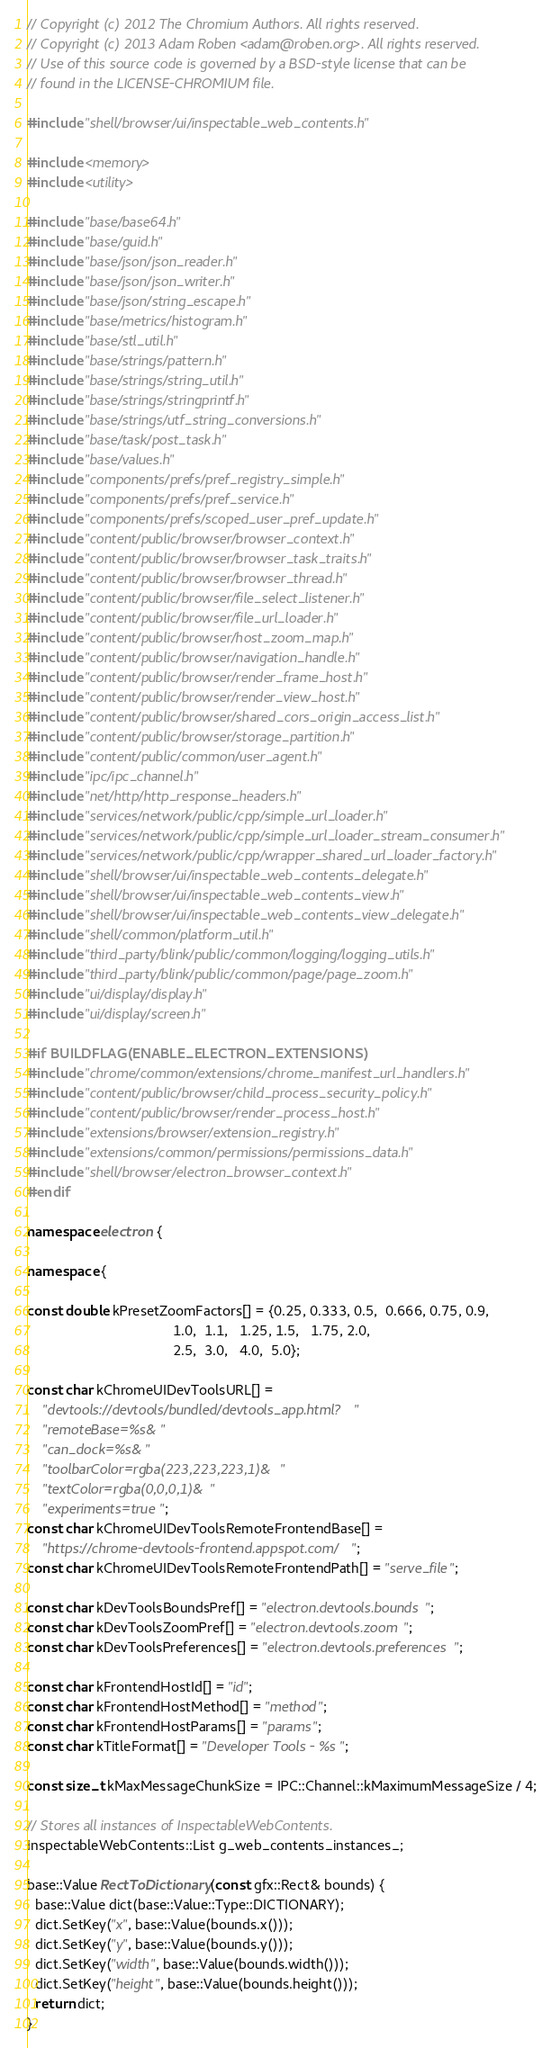<code> <loc_0><loc_0><loc_500><loc_500><_C++_>// Copyright (c) 2012 The Chromium Authors. All rights reserved.
// Copyright (c) 2013 Adam Roben <adam@roben.org>. All rights reserved.
// Use of this source code is governed by a BSD-style license that can be
// found in the LICENSE-CHROMIUM file.

#include "shell/browser/ui/inspectable_web_contents.h"

#include <memory>
#include <utility>

#include "base/base64.h"
#include "base/guid.h"
#include "base/json/json_reader.h"
#include "base/json/json_writer.h"
#include "base/json/string_escape.h"
#include "base/metrics/histogram.h"
#include "base/stl_util.h"
#include "base/strings/pattern.h"
#include "base/strings/string_util.h"
#include "base/strings/stringprintf.h"
#include "base/strings/utf_string_conversions.h"
#include "base/task/post_task.h"
#include "base/values.h"
#include "components/prefs/pref_registry_simple.h"
#include "components/prefs/pref_service.h"
#include "components/prefs/scoped_user_pref_update.h"
#include "content/public/browser/browser_context.h"
#include "content/public/browser/browser_task_traits.h"
#include "content/public/browser/browser_thread.h"
#include "content/public/browser/file_select_listener.h"
#include "content/public/browser/file_url_loader.h"
#include "content/public/browser/host_zoom_map.h"
#include "content/public/browser/navigation_handle.h"
#include "content/public/browser/render_frame_host.h"
#include "content/public/browser/render_view_host.h"
#include "content/public/browser/shared_cors_origin_access_list.h"
#include "content/public/browser/storage_partition.h"
#include "content/public/common/user_agent.h"
#include "ipc/ipc_channel.h"
#include "net/http/http_response_headers.h"
#include "services/network/public/cpp/simple_url_loader.h"
#include "services/network/public/cpp/simple_url_loader_stream_consumer.h"
#include "services/network/public/cpp/wrapper_shared_url_loader_factory.h"
#include "shell/browser/ui/inspectable_web_contents_delegate.h"
#include "shell/browser/ui/inspectable_web_contents_view.h"
#include "shell/browser/ui/inspectable_web_contents_view_delegate.h"
#include "shell/common/platform_util.h"
#include "third_party/blink/public/common/logging/logging_utils.h"
#include "third_party/blink/public/common/page/page_zoom.h"
#include "ui/display/display.h"
#include "ui/display/screen.h"

#if BUILDFLAG(ENABLE_ELECTRON_EXTENSIONS)
#include "chrome/common/extensions/chrome_manifest_url_handlers.h"
#include "content/public/browser/child_process_security_policy.h"
#include "content/public/browser/render_process_host.h"
#include "extensions/browser/extension_registry.h"
#include "extensions/common/permissions/permissions_data.h"
#include "shell/browser/electron_browser_context.h"
#endif

namespace electron {

namespace {

const double kPresetZoomFactors[] = {0.25, 0.333, 0.5,  0.666, 0.75, 0.9,
                                     1.0,  1.1,   1.25, 1.5,   1.75, 2.0,
                                     2.5,  3.0,   4.0,  5.0};

const char kChromeUIDevToolsURL[] =
    "devtools://devtools/bundled/devtools_app.html?"
    "remoteBase=%s&"
    "can_dock=%s&"
    "toolbarColor=rgba(223,223,223,1)&"
    "textColor=rgba(0,0,0,1)&"
    "experiments=true";
const char kChromeUIDevToolsRemoteFrontendBase[] =
    "https://chrome-devtools-frontend.appspot.com/";
const char kChromeUIDevToolsRemoteFrontendPath[] = "serve_file";

const char kDevToolsBoundsPref[] = "electron.devtools.bounds";
const char kDevToolsZoomPref[] = "electron.devtools.zoom";
const char kDevToolsPreferences[] = "electron.devtools.preferences";

const char kFrontendHostId[] = "id";
const char kFrontendHostMethod[] = "method";
const char kFrontendHostParams[] = "params";
const char kTitleFormat[] = "Developer Tools - %s";

const size_t kMaxMessageChunkSize = IPC::Channel::kMaximumMessageSize / 4;

// Stores all instances of InspectableWebContents.
InspectableWebContents::List g_web_contents_instances_;

base::Value RectToDictionary(const gfx::Rect& bounds) {
  base::Value dict(base::Value::Type::DICTIONARY);
  dict.SetKey("x", base::Value(bounds.x()));
  dict.SetKey("y", base::Value(bounds.y()));
  dict.SetKey("width", base::Value(bounds.width()));
  dict.SetKey("height", base::Value(bounds.height()));
  return dict;
}
</code> 